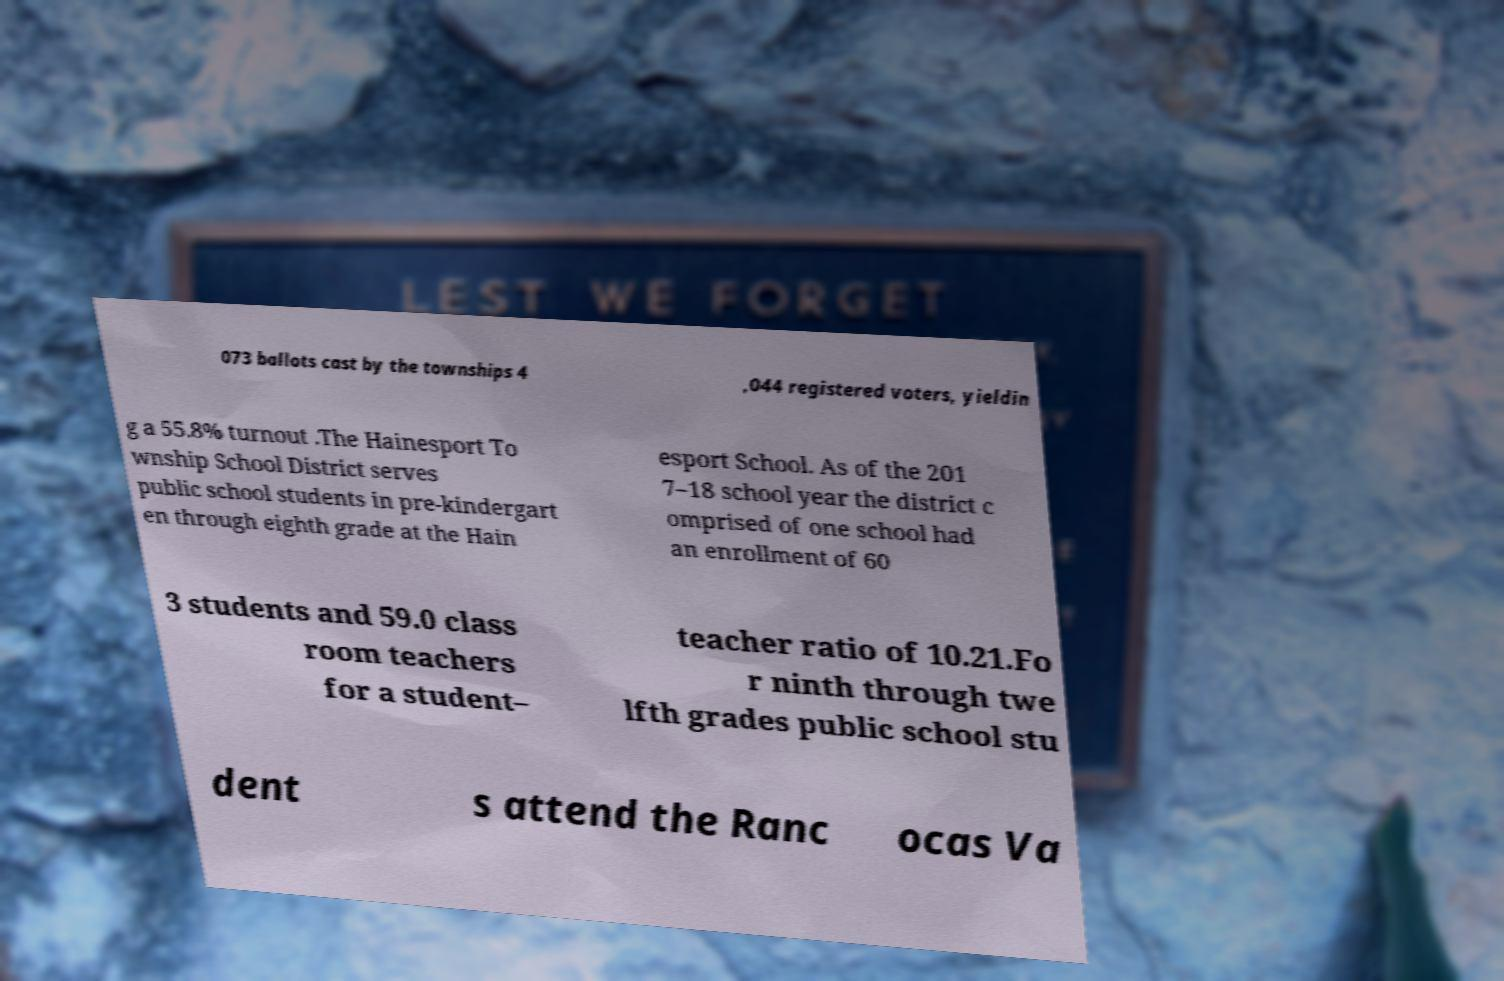Can you accurately transcribe the text from the provided image for me? 073 ballots cast by the townships 4 ,044 registered voters, yieldin g a 55.8% turnout .The Hainesport To wnship School District serves public school students in pre-kindergart en through eighth grade at the Hain esport School. As of the 201 7–18 school year the district c omprised of one school had an enrollment of 60 3 students and 59.0 class room teachers for a student– teacher ratio of 10.21.Fo r ninth through twe lfth grades public school stu dent s attend the Ranc ocas Va 